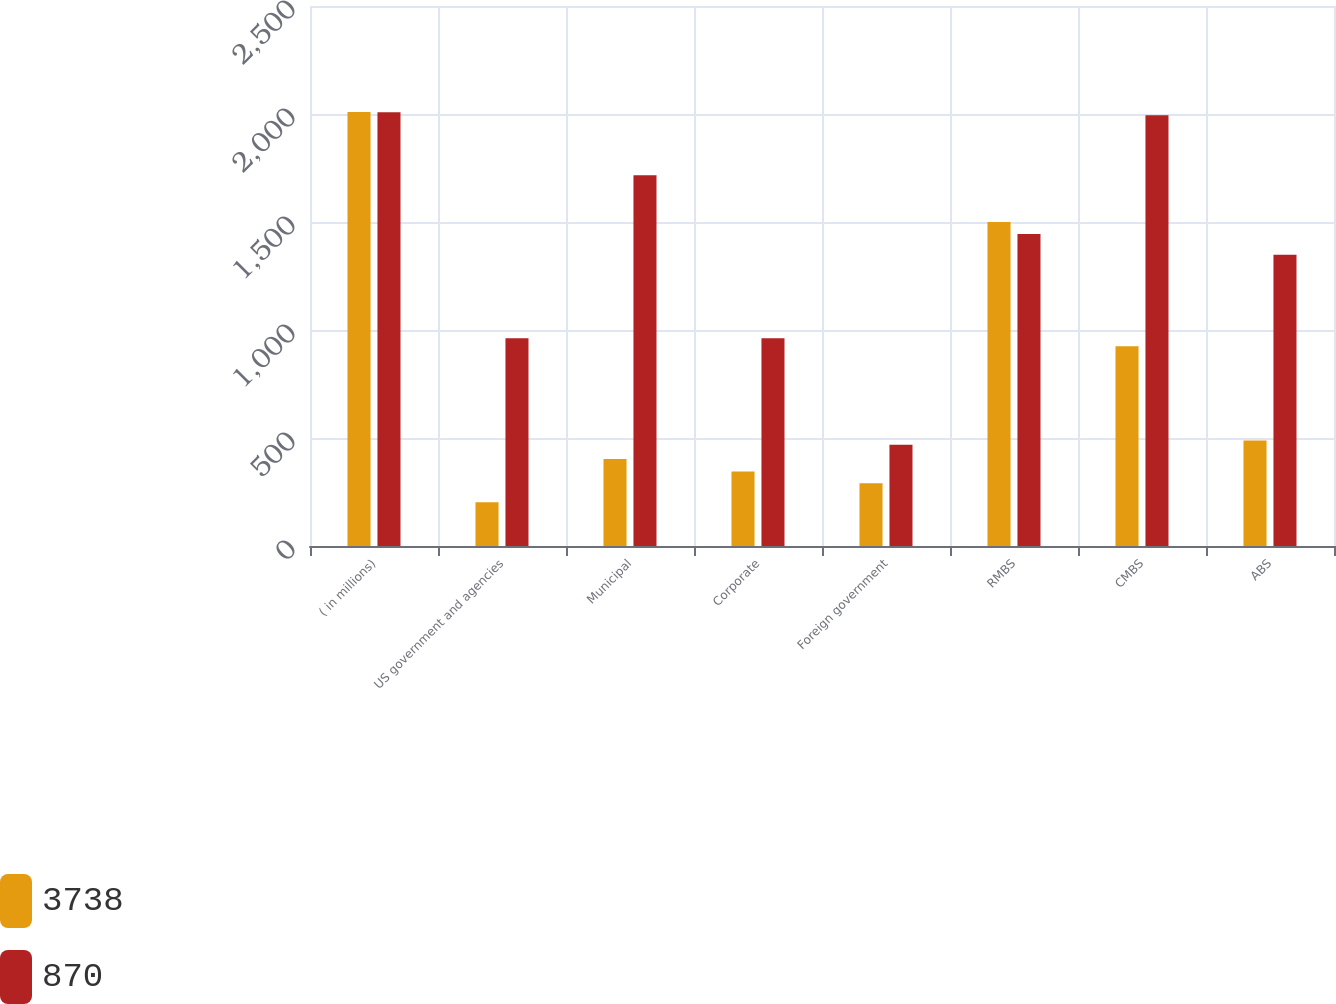Convert chart. <chart><loc_0><loc_0><loc_500><loc_500><stacked_bar_chart><ecel><fcel>( in millions)<fcel>US government and agencies<fcel>Municipal<fcel>Corporate<fcel>Foreign government<fcel>RMBS<fcel>CMBS<fcel>ABS<nl><fcel>3738<fcel>2009<fcel>203<fcel>403<fcel>345<fcel>291<fcel>1500<fcel>925<fcel>488<nl><fcel>870<fcel>2008<fcel>962<fcel>1717<fcel>962<fcel>469<fcel>1445<fcel>1994<fcel>1348<nl></chart> 